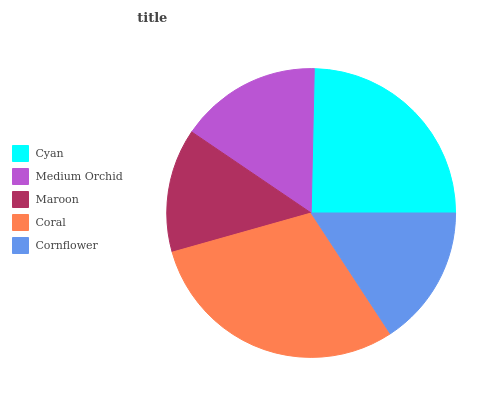Is Maroon the minimum?
Answer yes or no. Yes. Is Coral the maximum?
Answer yes or no. Yes. Is Medium Orchid the minimum?
Answer yes or no. No. Is Medium Orchid the maximum?
Answer yes or no. No. Is Cyan greater than Medium Orchid?
Answer yes or no. Yes. Is Medium Orchid less than Cyan?
Answer yes or no. Yes. Is Medium Orchid greater than Cyan?
Answer yes or no. No. Is Cyan less than Medium Orchid?
Answer yes or no. No. Is Medium Orchid the high median?
Answer yes or no. Yes. Is Medium Orchid the low median?
Answer yes or no. Yes. Is Maroon the high median?
Answer yes or no. No. Is Maroon the low median?
Answer yes or no. No. 